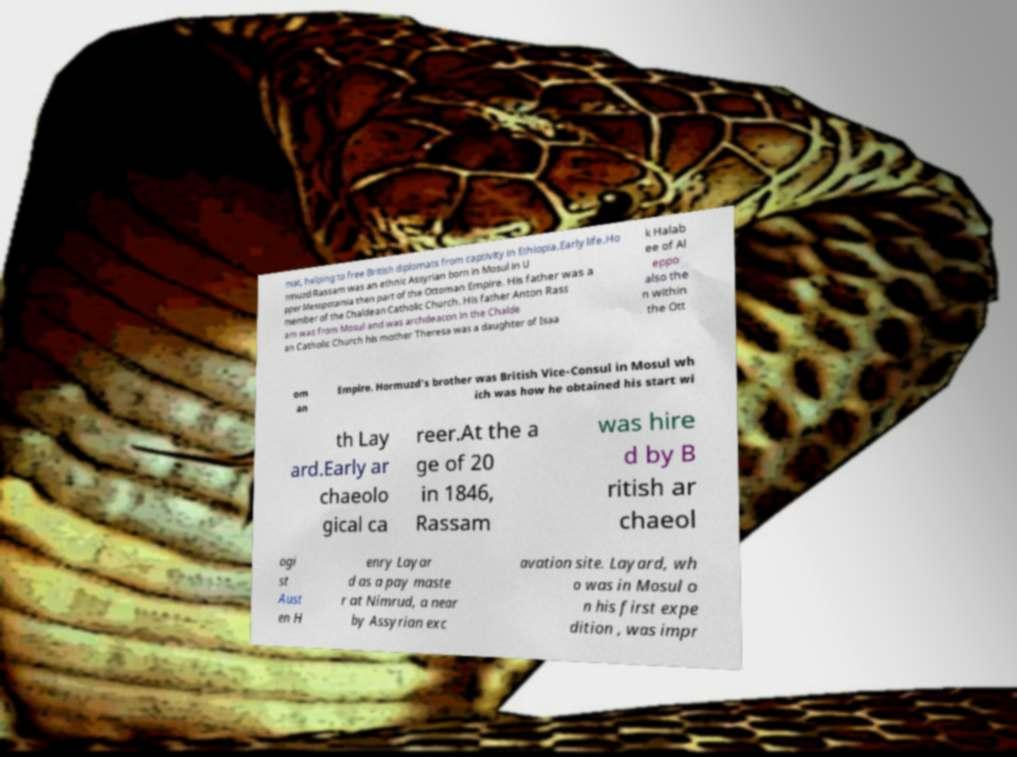Could you assist in decoding the text presented in this image and type it out clearly? mat, helping to free British diplomats from captivity in Ethiopia.Early life.Ho rmuzd Rassam was an ethnic Assyrian born in Mosul in U pper Mesopotamia then part of the Ottoman Empire. His father was a member of the Chaldean Catholic Church. His father Anton Rass am was from Mosul and was archdeacon in the Chalde an Catholic Church his mother Theresa was a daughter of Isaa k Halab ee of Al eppo also the n within the Ott om an Empire. Hormuzd's brother was British Vice-Consul in Mosul wh ich was how he obtained his start wi th Lay ard.Early ar chaeolo gical ca reer.At the a ge of 20 in 1846, Rassam was hire d by B ritish ar chaeol ogi st Aust en H enry Layar d as a pay maste r at Nimrud, a near by Assyrian exc avation site. Layard, wh o was in Mosul o n his first expe dition , was impr 